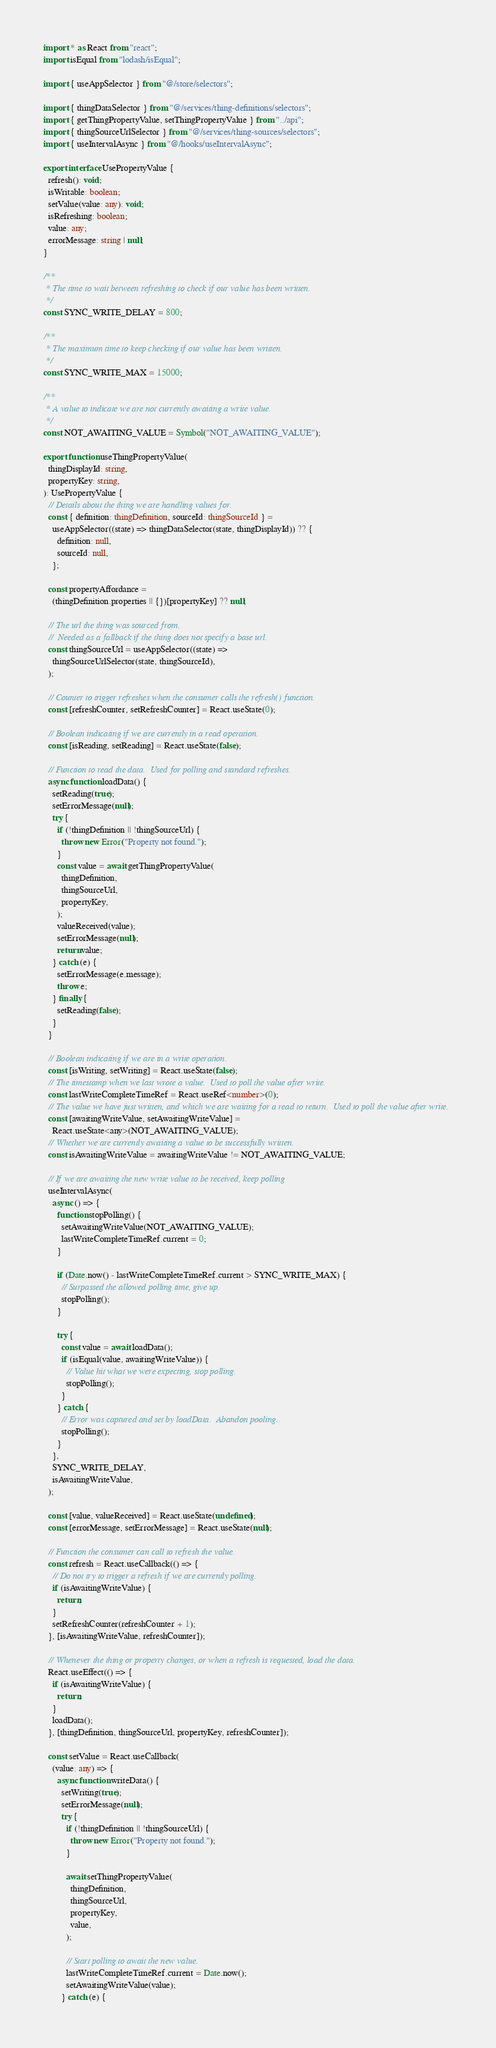Convert code to text. <code><loc_0><loc_0><loc_500><loc_500><_TypeScript_>import * as React from "react";
import isEqual from "lodash/isEqual";

import { useAppSelector } from "@/store/selectors";

import { thingDataSelector } from "@/services/thing-definitions/selectors";
import { getThingPropertyValue, setThingPropertyValue } from "../api";
import { thingSourceUrlSelector } from "@/services/thing-sources/selectors";
import { useIntervalAsync } from "@/hooks/useIntervalAsync";

export interface UsePropertyValue {
  refresh(): void;
  isWritable: boolean;
  setValue(value: any): void;
  isRefreshing: boolean;
  value: any;
  errorMessage: string | null;
}

/**
 * The time to wait between refreshing to check if our value has been written.
 */
const SYNC_WRITE_DELAY = 800;

/**
 * The maximum time to keep checking if our value has been written.
 */
const SYNC_WRITE_MAX = 15000;

/**
 * A value to indicate we are not currently awaiting a write value.
 */
const NOT_AWAITING_VALUE = Symbol("NOT_AWAITING_VALUE");

export function useThingPropertyValue(
  thingDisplayId: string,
  propertyKey: string,
): UsePropertyValue {
  // Details about the thing we are handling values for.
  const { definition: thingDefinition, sourceId: thingSourceId } =
    useAppSelector((state) => thingDataSelector(state, thingDisplayId)) ?? {
      definition: null,
      sourceId: null,
    };

  const propertyAffordance =
    (thingDefinition.properties || {})[propertyKey] ?? null;

  // The url the thing was sourced from.
  //  Needed as a fallback if the thing does not specify a base url.
  const thingSourceUrl = useAppSelector((state) =>
    thingSourceUrlSelector(state, thingSourceId),
  );

  // Counter to trigger refreshes when the consumer calls the refresh() function.
  const [refreshCounter, setRefreshCounter] = React.useState(0);

  // Boolean indicating if we are currently in a read operation.
  const [isReading, setReading] = React.useState(false);

  // Function to read the data.  Used for polling and standard refreshes.
  async function loadData() {
    setReading(true);
    setErrorMessage(null);
    try {
      if (!thingDefinition || !thingSourceUrl) {
        throw new Error("Property not found.");
      }
      const value = await getThingPropertyValue(
        thingDefinition,
        thingSourceUrl,
        propertyKey,
      );
      valueReceived(value);
      setErrorMessage(null);
      return value;
    } catch (e) {
      setErrorMessage(e.message);
      throw e;
    } finally {
      setReading(false);
    }
  }

  // Boolean indicating if we are in a write operation.
  const [isWriting, setWriting] = React.useState(false);
  // The timestamp when we last wrote a value.  Used to poll the value after write.
  const lastWriteCompleteTimeRef = React.useRef<number>(0);
  // The value we have just written, and which we are waiting for a read to return.  Used to poll the value after write.
  const [awaitingWriteValue, setAwaitingWriteValue] =
    React.useState<any>(NOT_AWAITING_VALUE);
  // Whether we are currently awaiting a value to be successfully written.
  const isAwaitingWriteValue = awaitingWriteValue != NOT_AWAITING_VALUE;

  // If we are awaiting the new write value to be received, keep polling
  useIntervalAsync(
    async () => {
      function stopPolling() {
        setAwaitingWriteValue(NOT_AWAITING_VALUE);
        lastWriteCompleteTimeRef.current = 0;
      }

      if (Date.now() - lastWriteCompleteTimeRef.current > SYNC_WRITE_MAX) {
        // Surpassed the allowed polling time, give up.
        stopPolling();
      }

      try {
        const value = await loadData();
        if (isEqual(value, awaitingWriteValue)) {
          // Value hit what we were expecting, stop polling.
          stopPolling();
        }
      } catch {
        // Error was captured and set by loadData.  Abandon pooling.
        stopPolling();
      }
    },
    SYNC_WRITE_DELAY,
    isAwaitingWriteValue,
  );

  const [value, valueReceived] = React.useState(undefined);
  const [errorMessage, setErrorMessage] = React.useState(null);

  // Function the consumer can call to refresh the value.
  const refresh = React.useCallback(() => {
    // Do not try to trigger a refresh if we are currently polling.
    if (isAwaitingWriteValue) {
      return;
    }
    setRefreshCounter(refreshCounter + 1);
  }, [isAwaitingWriteValue, refreshCounter]);

  // Whenever the thing or property changes, or when a refresh is requested, load the data.
  React.useEffect(() => {
    if (isAwaitingWriteValue) {
      return;
    }
    loadData();
  }, [thingDefinition, thingSourceUrl, propertyKey, refreshCounter]);

  const setValue = React.useCallback(
    (value: any) => {
      async function writeData() {
        setWriting(true);
        setErrorMessage(null);
        try {
          if (!thingDefinition || !thingSourceUrl) {
            throw new Error("Property not found.");
          }

          await setThingPropertyValue(
            thingDefinition,
            thingSourceUrl,
            propertyKey,
            value,
          );

          // Start polling to await the new value.
          lastWriteCompleteTimeRef.current = Date.now();
          setAwaitingWriteValue(value);
        } catch (e) {</code> 